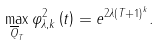<formula> <loc_0><loc_0><loc_500><loc_500>\max _ { \overline { Q } _ { T } } \varphi _ { \lambda , k } ^ { 2 } \left ( t \right ) = e ^ { 2 \lambda \left ( T + 1 \right ) ^ { k } } .</formula> 